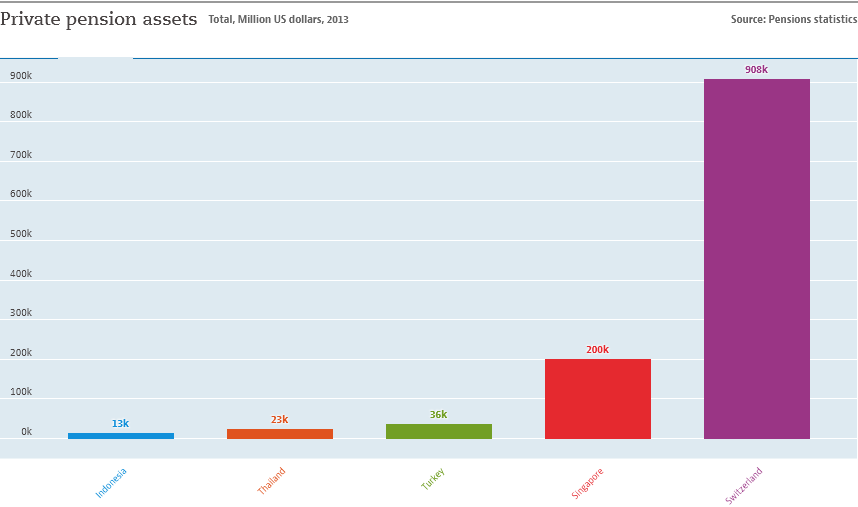Give some essential details in this illustration. There are 5 places where assets are present in the chart. The sum of the lowest two values is equal to the value of Turkey. 